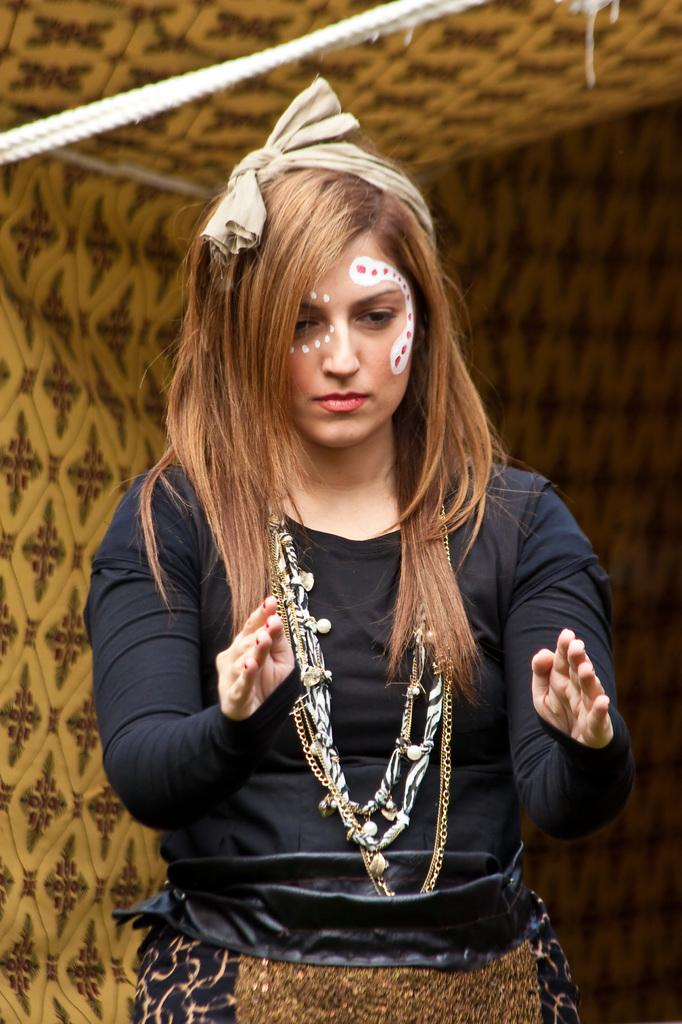Who is present in the image? There is a woman in the image. What is the woman wearing in the image? The woman is wearing long chains in the image. How is the woman's appearance different from her natural state? The woman has different makeup in the image. What other objects can be seen in the image? There is a rope and cloth in the image. What type of song can be heard playing in the background of the image? There is no indication of any music or sound in the image, so it is not possible to determine what song might be playing. 